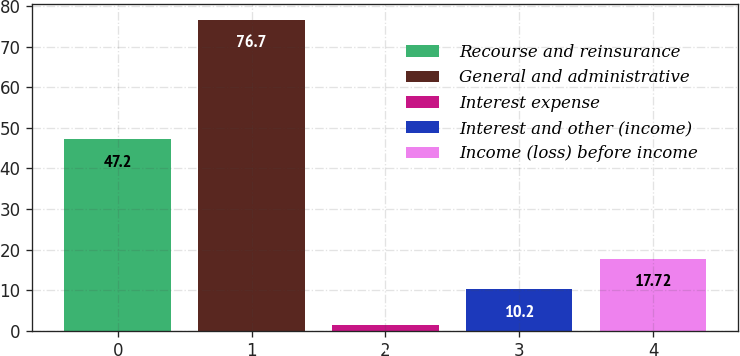Convert chart. <chart><loc_0><loc_0><loc_500><loc_500><bar_chart><fcel>Recourse and reinsurance<fcel>General and administrative<fcel>Interest expense<fcel>Interest and other (income)<fcel>Income (loss) before income<nl><fcel>47.2<fcel>76.7<fcel>1.5<fcel>10.2<fcel>17.72<nl></chart> 